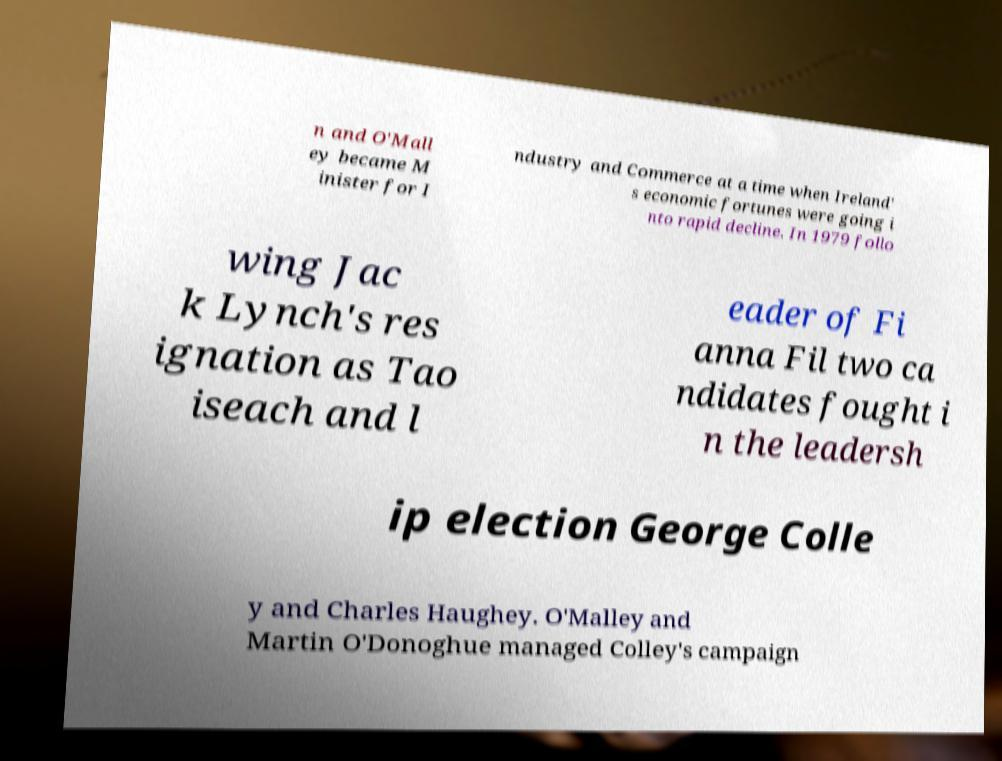Can you read and provide the text displayed in the image?This photo seems to have some interesting text. Can you extract and type it out for me? n and O'Mall ey became M inister for I ndustry and Commerce at a time when Ireland' s economic fortunes were going i nto rapid decline. In 1979 follo wing Jac k Lynch's res ignation as Tao iseach and l eader of Fi anna Fil two ca ndidates fought i n the leadersh ip election George Colle y and Charles Haughey. O'Malley and Martin O'Donoghue managed Colley's campaign 